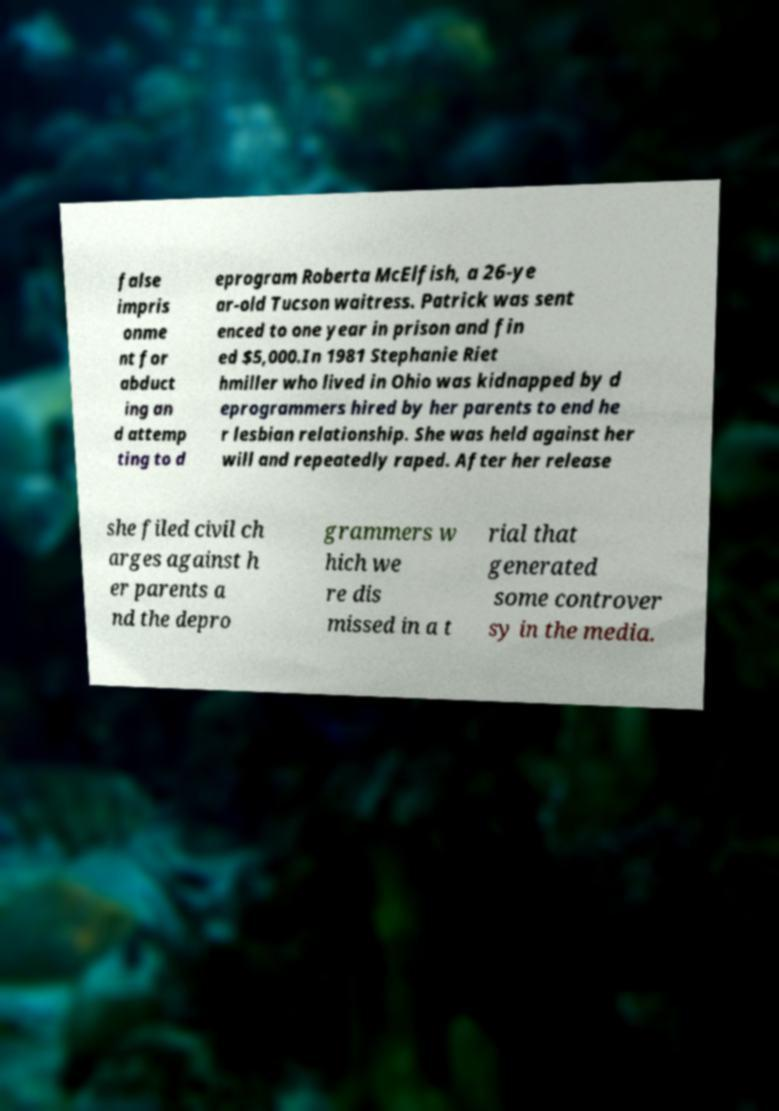I need the written content from this picture converted into text. Can you do that? false impris onme nt for abduct ing an d attemp ting to d eprogram Roberta McElfish, a 26-ye ar-old Tucson waitress. Patrick was sent enced to one year in prison and fin ed $5,000.In 1981 Stephanie Riet hmiller who lived in Ohio was kidnapped by d eprogrammers hired by her parents to end he r lesbian relationship. She was held against her will and repeatedly raped. After her release she filed civil ch arges against h er parents a nd the depro grammers w hich we re dis missed in a t rial that generated some controver sy in the media. 